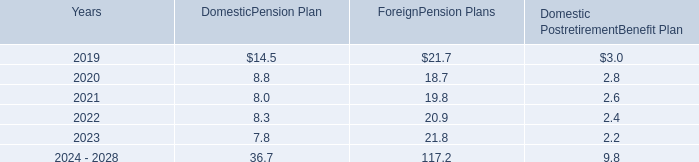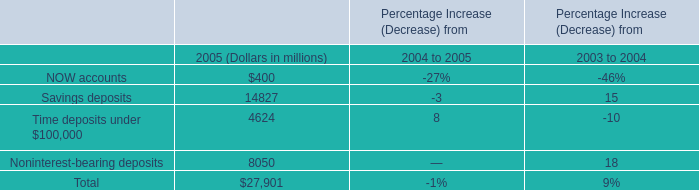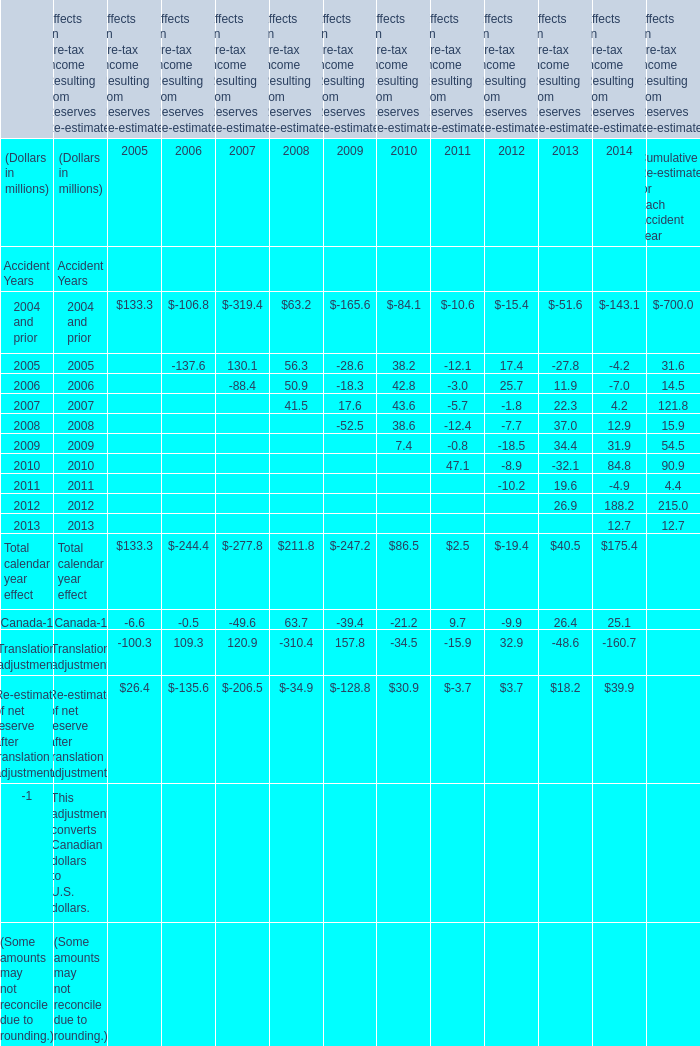in 2018 what was the net discretionary company contribution after the participant forfeitures 
Computations: (6.7 - 5.8)
Answer: 0.9. 